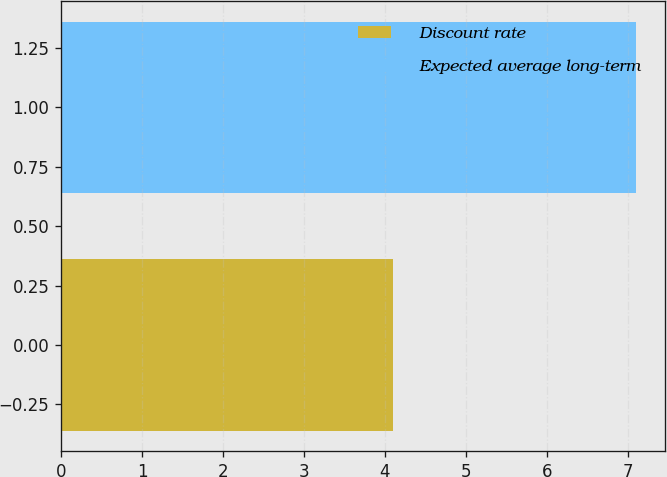Convert chart. <chart><loc_0><loc_0><loc_500><loc_500><bar_chart><fcel>Discount rate<fcel>Expected average long-term<nl><fcel>4.1<fcel>7.11<nl></chart> 